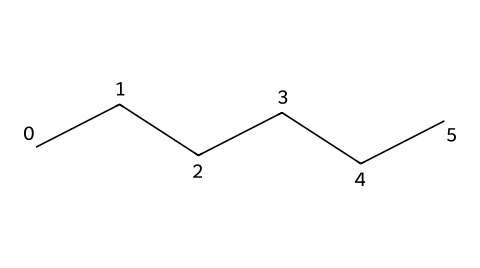What is the molecular formula of hexane? The molecular formula can be derived from the SMILES notation "CCCCCC", which indicates six carbon (C) atoms and, by typical hydrocarbon bonding patterns, twelve hydrogen (H) atoms. Therefore, the formula is C6H14.
Answer: C6H14 How many carbon atoms are in hexane? The SMILES representation shows six sequential carbon atoms (CCCCCC), indicating the total number of carbon atoms present is six.
Answer: 6 What type of bonding is present in hexane? Hexane comprises single bonds between carbon atoms (indicated by the simplicity of the SMILES). This denotes that all bonding is through sigma bonds, typical of alkanes, which consist solely of single bonds.
Answer: single bonds Is hexane a saturated or unsaturated hydrocarbon? Since hexane consists of only single bonds (CCCCCC) and contains the maximum possible number of hydrogen atoms for the number of carbon atoms, it is classified as a saturated hydrocarbon.
Answer: saturated What makes hexane flammable? Hexane contains a significant amount of carbon and hydrogen, which, under the right conditions (like high temperatures), can combust, producing heat and light. The structure allows for easy vaporization, which is necessary for flammability.
Answer: carbon and hydrogen How many hydrogen atoms are attached to each carbon in hexane? The molecular structure (C6H14) shows that in a fully saturated alkane like hexane, each terminal carbon is bonded to three hydrogen atoms, while the internal carbons are bonded to two hydrogens. Thus, they vary between 2 and 3 hydrogens per carbon, averaging around 2.33 overall.
Answer: 2 or 3 Can hexane dissolve polar substances? Hexane is a non-polar solvent due to its symmetrical structure and lack of significant electronegative atoms, making it ineffective in dissolving polar substances, which rely on dipole interactions that hexane lacks.
Answer: no 